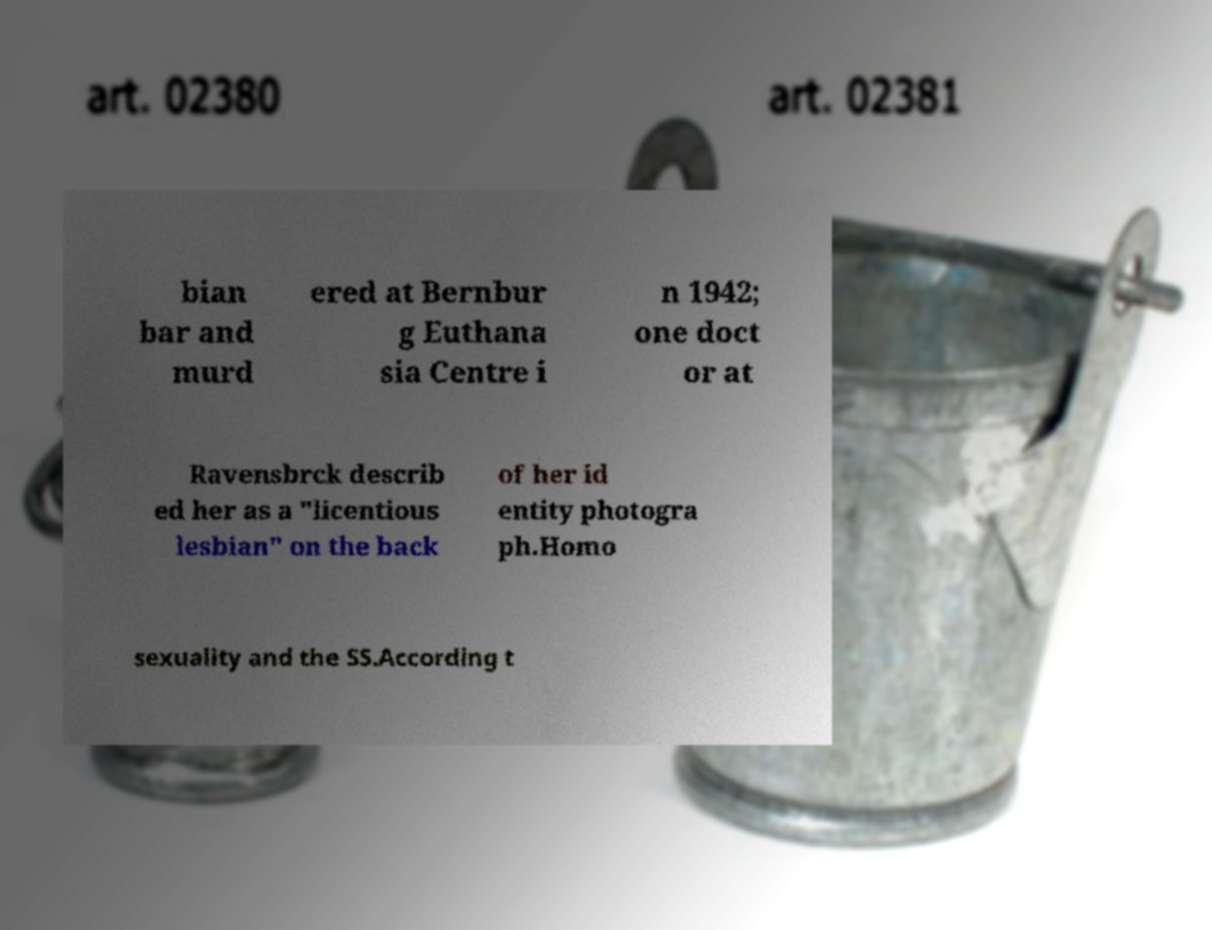I need the written content from this picture converted into text. Can you do that? bian bar and murd ered at Bernbur g Euthana sia Centre i n 1942; one doct or at Ravensbrck describ ed her as a "licentious lesbian" on the back of her id entity photogra ph.Homo sexuality and the SS.According t 